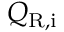<formula> <loc_0><loc_0><loc_500><loc_500>Q _ { R , i }</formula> 